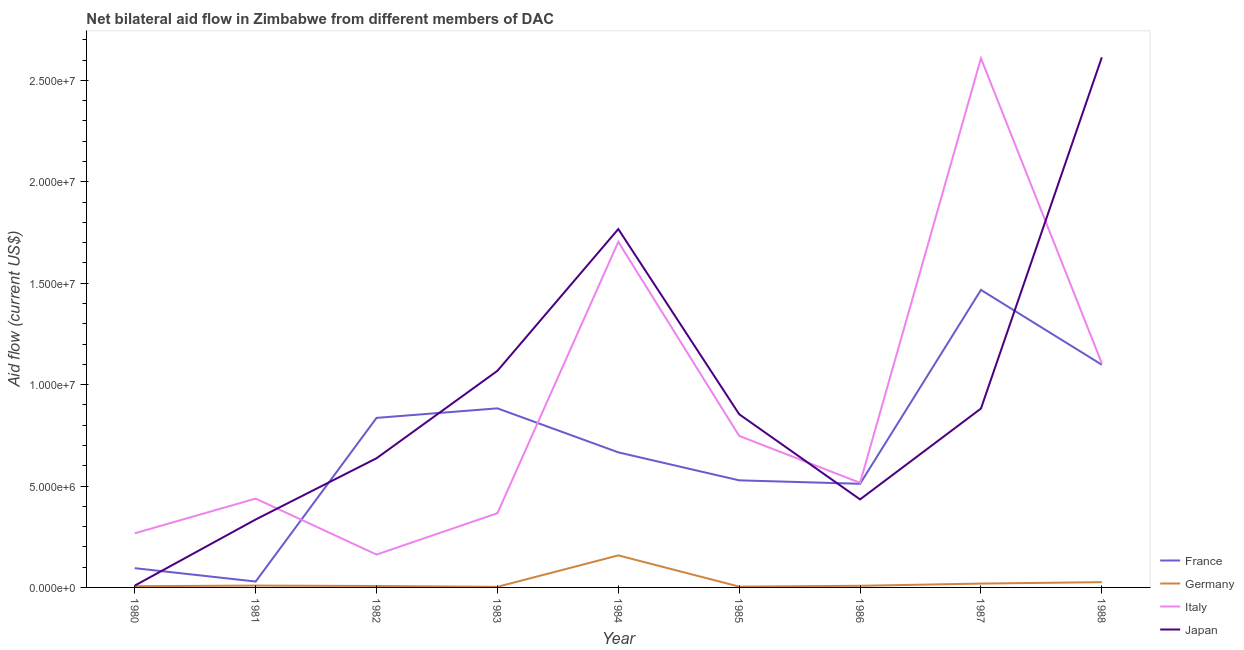How many different coloured lines are there?
Provide a succinct answer. 4. Does the line corresponding to amount of aid given by germany intersect with the line corresponding to amount of aid given by japan?
Offer a very short reply. No. Is the number of lines equal to the number of legend labels?
Your answer should be compact. Yes. What is the amount of aid given by italy in 1983?
Ensure brevity in your answer.  3.66e+06. Across all years, what is the maximum amount of aid given by france?
Keep it short and to the point. 1.47e+07. Across all years, what is the minimum amount of aid given by france?
Give a very brief answer. 2.90e+05. In which year was the amount of aid given by france minimum?
Offer a very short reply. 1981. What is the total amount of aid given by france in the graph?
Provide a short and direct response. 6.11e+07. What is the difference between the amount of aid given by japan in 1980 and that in 1988?
Provide a short and direct response. -2.60e+07. What is the difference between the amount of aid given by france in 1985 and the amount of aid given by italy in 1987?
Ensure brevity in your answer.  -2.08e+07. What is the average amount of aid given by france per year?
Provide a succinct answer. 6.79e+06. In the year 1983, what is the difference between the amount of aid given by germany and amount of aid given by italy?
Keep it short and to the point. -3.63e+06. In how many years, is the amount of aid given by germany greater than 19000000 US$?
Make the answer very short. 0. What is the ratio of the amount of aid given by japan in 1986 to that in 1987?
Offer a very short reply. 0.49. What is the difference between the highest and the second highest amount of aid given by japan?
Make the answer very short. 8.47e+06. What is the difference between the highest and the lowest amount of aid given by italy?
Give a very brief answer. 2.45e+07. In how many years, is the amount of aid given by france greater than the average amount of aid given by france taken over all years?
Keep it short and to the point. 4. Is it the case that in every year, the sum of the amount of aid given by france and amount of aid given by germany is greater than the sum of amount of aid given by japan and amount of aid given by italy?
Your answer should be compact. No. Is it the case that in every year, the sum of the amount of aid given by france and amount of aid given by germany is greater than the amount of aid given by italy?
Offer a very short reply. No. How many years are there in the graph?
Provide a short and direct response. 9. What is the difference between two consecutive major ticks on the Y-axis?
Offer a terse response. 5.00e+06. Are the values on the major ticks of Y-axis written in scientific E-notation?
Offer a very short reply. Yes. Where does the legend appear in the graph?
Provide a short and direct response. Bottom right. How many legend labels are there?
Provide a short and direct response. 4. What is the title of the graph?
Provide a succinct answer. Net bilateral aid flow in Zimbabwe from different members of DAC. Does "Tertiary schools" appear as one of the legend labels in the graph?
Keep it short and to the point. No. What is the label or title of the X-axis?
Keep it short and to the point. Year. What is the Aid flow (current US$) in France in 1980?
Keep it short and to the point. 9.50e+05. What is the Aid flow (current US$) in Germany in 1980?
Your response must be concise. 6.00e+04. What is the Aid flow (current US$) of Italy in 1980?
Offer a terse response. 2.67e+06. What is the Aid flow (current US$) in Japan in 1980?
Give a very brief answer. 9.00e+04. What is the Aid flow (current US$) in Germany in 1981?
Ensure brevity in your answer.  9.00e+04. What is the Aid flow (current US$) of Italy in 1981?
Your response must be concise. 4.38e+06. What is the Aid flow (current US$) of Japan in 1981?
Your answer should be compact. 3.35e+06. What is the Aid flow (current US$) of France in 1982?
Give a very brief answer. 8.36e+06. What is the Aid flow (current US$) in Italy in 1982?
Provide a succinct answer. 1.62e+06. What is the Aid flow (current US$) in Japan in 1982?
Provide a succinct answer. 6.37e+06. What is the Aid flow (current US$) of France in 1983?
Make the answer very short. 8.83e+06. What is the Aid flow (current US$) in Germany in 1983?
Your answer should be very brief. 3.00e+04. What is the Aid flow (current US$) in Italy in 1983?
Provide a succinct answer. 3.66e+06. What is the Aid flow (current US$) of Japan in 1983?
Give a very brief answer. 1.07e+07. What is the Aid flow (current US$) of France in 1984?
Give a very brief answer. 6.66e+06. What is the Aid flow (current US$) in Germany in 1984?
Your answer should be very brief. 1.58e+06. What is the Aid flow (current US$) of Italy in 1984?
Your answer should be very brief. 1.70e+07. What is the Aid flow (current US$) in Japan in 1984?
Make the answer very short. 1.77e+07. What is the Aid flow (current US$) of France in 1985?
Your response must be concise. 5.28e+06. What is the Aid flow (current US$) of Germany in 1985?
Keep it short and to the point. 4.00e+04. What is the Aid flow (current US$) of Italy in 1985?
Keep it short and to the point. 7.47e+06. What is the Aid flow (current US$) of Japan in 1985?
Your answer should be very brief. 8.54e+06. What is the Aid flow (current US$) of France in 1986?
Offer a terse response. 5.11e+06. What is the Aid flow (current US$) in Germany in 1986?
Offer a very short reply. 8.00e+04. What is the Aid flow (current US$) of Italy in 1986?
Offer a very short reply. 5.16e+06. What is the Aid flow (current US$) of Japan in 1986?
Your answer should be compact. 4.34e+06. What is the Aid flow (current US$) of France in 1987?
Your response must be concise. 1.47e+07. What is the Aid flow (current US$) in Italy in 1987?
Ensure brevity in your answer.  2.61e+07. What is the Aid flow (current US$) in Japan in 1987?
Offer a very short reply. 8.82e+06. What is the Aid flow (current US$) of France in 1988?
Your response must be concise. 1.10e+07. What is the Aid flow (current US$) in Italy in 1988?
Make the answer very short. 1.10e+07. What is the Aid flow (current US$) in Japan in 1988?
Offer a very short reply. 2.61e+07. Across all years, what is the maximum Aid flow (current US$) of France?
Make the answer very short. 1.47e+07. Across all years, what is the maximum Aid flow (current US$) of Germany?
Provide a succinct answer. 1.58e+06. Across all years, what is the maximum Aid flow (current US$) in Italy?
Ensure brevity in your answer.  2.61e+07. Across all years, what is the maximum Aid flow (current US$) of Japan?
Provide a short and direct response. 2.61e+07. Across all years, what is the minimum Aid flow (current US$) in Germany?
Your response must be concise. 3.00e+04. Across all years, what is the minimum Aid flow (current US$) in Italy?
Provide a succinct answer. 1.62e+06. Across all years, what is the minimum Aid flow (current US$) in Japan?
Make the answer very short. 9.00e+04. What is the total Aid flow (current US$) in France in the graph?
Provide a succinct answer. 6.11e+07. What is the total Aid flow (current US$) of Germany in the graph?
Keep it short and to the point. 2.40e+06. What is the total Aid flow (current US$) of Italy in the graph?
Your answer should be compact. 7.91e+07. What is the total Aid flow (current US$) of Japan in the graph?
Provide a succinct answer. 8.60e+07. What is the difference between the Aid flow (current US$) in France in 1980 and that in 1981?
Provide a short and direct response. 6.60e+05. What is the difference between the Aid flow (current US$) in Germany in 1980 and that in 1981?
Provide a succinct answer. -3.00e+04. What is the difference between the Aid flow (current US$) of Italy in 1980 and that in 1981?
Your answer should be compact. -1.71e+06. What is the difference between the Aid flow (current US$) in Japan in 1980 and that in 1981?
Your answer should be very brief. -3.26e+06. What is the difference between the Aid flow (current US$) in France in 1980 and that in 1982?
Provide a short and direct response. -7.41e+06. What is the difference between the Aid flow (current US$) in Italy in 1980 and that in 1982?
Keep it short and to the point. 1.05e+06. What is the difference between the Aid flow (current US$) in Japan in 1980 and that in 1982?
Offer a terse response. -6.28e+06. What is the difference between the Aid flow (current US$) in France in 1980 and that in 1983?
Offer a terse response. -7.88e+06. What is the difference between the Aid flow (current US$) of Italy in 1980 and that in 1983?
Keep it short and to the point. -9.90e+05. What is the difference between the Aid flow (current US$) in Japan in 1980 and that in 1983?
Provide a short and direct response. -1.06e+07. What is the difference between the Aid flow (current US$) of France in 1980 and that in 1984?
Offer a very short reply. -5.71e+06. What is the difference between the Aid flow (current US$) of Germany in 1980 and that in 1984?
Provide a short and direct response. -1.52e+06. What is the difference between the Aid flow (current US$) of Italy in 1980 and that in 1984?
Your response must be concise. -1.44e+07. What is the difference between the Aid flow (current US$) in Japan in 1980 and that in 1984?
Offer a very short reply. -1.76e+07. What is the difference between the Aid flow (current US$) in France in 1980 and that in 1985?
Give a very brief answer. -4.33e+06. What is the difference between the Aid flow (current US$) in Germany in 1980 and that in 1985?
Provide a succinct answer. 2.00e+04. What is the difference between the Aid flow (current US$) in Italy in 1980 and that in 1985?
Offer a very short reply. -4.80e+06. What is the difference between the Aid flow (current US$) of Japan in 1980 and that in 1985?
Make the answer very short. -8.45e+06. What is the difference between the Aid flow (current US$) in France in 1980 and that in 1986?
Offer a terse response. -4.16e+06. What is the difference between the Aid flow (current US$) of Italy in 1980 and that in 1986?
Offer a very short reply. -2.49e+06. What is the difference between the Aid flow (current US$) of Japan in 1980 and that in 1986?
Provide a succinct answer. -4.25e+06. What is the difference between the Aid flow (current US$) of France in 1980 and that in 1987?
Provide a succinct answer. -1.37e+07. What is the difference between the Aid flow (current US$) in Italy in 1980 and that in 1987?
Ensure brevity in your answer.  -2.34e+07. What is the difference between the Aid flow (current US$) in Japan in 1980 and that in 1987?
Provide a short and direct response. -8.73e+06. What is the difference between the Aid flow (current US$) of France in 1980 and that in 1988?
Offer a very short reply. -1.00e+07. What is the difference between the Aid flow (current US$) of Italy in 1980 and that in 1988?
Provide a succinct answer. -8.38e+06. What is the difference between the Aid flow (current US$) of Japan in 1980 and that in 1988?
Your answer should be very brief. -2.60e+07. What is the difference between the Aid flow (current US$) of France in 1981 and that in 1982?
Provide a short and direct response. -8.07e+06. What is the difference between the Aid flow (current US$) in Germany in 1981 and that in 1982?
Your response must be concise. 2.00e+04. What is the difference between the Aid flow (current US$) of Italy in 1981 and that in 1982?
Make the answer very short. 2.76e+06. What is the difference between the Aid flow (current US$) in Japan in 1981 and that in 1982?
Provide a succinct answer. -3.02e+06. What is the difference between the Aid flow (current US$) in France in 1981 and that in 1983?
Offer a terse response. -8.54e+06. What is the difference between the Aid flow (current US$) in Italy in 1981 and that in 1983?
Offer a terse response. 7.20e+05. What is the difference between the Aid flow (current US$) in Japan in 1981 and that in 1983?
Make the answer very short. -7.33e+06. What is the difference between the Aid flow (current US$) in France in 1981 and that in 1984?
Provide a succinct answer. -6.37e+06. What is the difference between the Aid flow (current US$) of Germany in 1981 and that in 1984?
Offer a terse response. -1.49e+06. What is the difference between the Aid flow (current US$) in Italy in 1981 and that in 1984?
Offer a terse response. -1.27e+07. What is the difference between the Aid flow (current US$) in Japan in 1981 and that in 1984?
Offer a terse response. -1.43e+07. What is the difference between the Aid flow (current US$) in France in 1981 and that in 1985?
Keep it short and to the point. -4.99e+06. What is the difference between the Aid flow (current US$) in Germany in 1981 and that in 1985?
Offer a terse response. 5.00e+04. What is the difference between the Aid flow (current US$) of Italy in 1981 and that in 1985?
Offer a terse response. -3.09e+06. What is the difference between the Aid flow (current US$) in Japan in 1981 and that in 1985?
Give a very brief answer. -5.19e+06. What is the difference between the Aid flow (current US$) in France in 1981 and that in 1986?
Your response must be concise. -4.82e+06. What is the difference between the Aid flow (current US$) of Italy in 1981 and that in 1986?
Your response must be concise. -7.80e+05. What is the difference between the Aid flow (current US$) of Japan in 1981 and that in 1986?
Provide a succinct answer. -9.90e+05. What is the difference between the Aid flow (current US$) of France in 1981 and that in 1987?
Offer a very short reply. -1.44e+07. What is the difference between the Aid flow (current US$) in Italy in 1981 and that in 1987?
Keep it short and to the point. -2.17e+07. What is the difference between the Aid flow (current US$) of Japan in 1981 and that in 1987?
Keep it short and to the point. -5.47e+06. What is the difference between the Aid flow (current US$) of France in 1981 and that in 1988?
Keep it short and to the point. -1.07e+07. What is the difference between the Aid flow (current US$) in Germany in 1981 and that in 1988?
Offer a very short reply. -1.70e+05. What is the difference between the Aid flow (current US$) of Italy in 1981 and that in 1988?
Make the answer very short. -6.67e+06. What is the difference between the Aid flow (current US$) in Japan in 1981 and that in 1988?
Offer a terse response. -2.28e+07. What is the difference between the Aid flow (current US$) of France in 1982 and that in 1983?
Provide a short and direct response. -4.70e+05. What is the difference between the Aid flow (current US$) in Germany in 1982 and that in 1983?
Your response must be concise. 4.00e+04. What is the difference between the Aid flow (current US$) in Italy in 1982 and that in 1983?
Your answer should be compact. -2.04e+06. What is the difference between the Aid flow (current US$) of Japan in 1982 and that in 1983?
Provide a short and direct response. -4.31e+06. What is the difference between the Aid flow (current US$) of France in 1982 and that in 1984?
Your answer should be very brief. 1.70e+06. What is the difference between the Aid flow (current US$) of Germany in 1982 and that in 1984?
Give a very brief answer. -1.51e+06. What is the difference between the Aid flow (current US$) of Italy in 1982 and that in 1984?
Keep it short and to the point. -1.54e+07. What is the difference between the Aid flow (current US$) of Japan in 1982 and that in 1984?
Ensure brevity in your answer.  -1.13e+07. What is the difference between the Aid flow (current US$) of France in 1982 and that in 1985?
Your answer should be very brief. 3.08e+06. What is the difference between the Aid flow (current US$) of Italy in 1982 and that in 1985?
Your response must be concise. -5.85e+06. What is the difference between the Aid flow (current US$) of Japan in 1982 and that in 1985?
Provide a short and direct response. -2.17e+06. What is the difference between the Aid flow (current US$) of France in 1982 and that in 1986?
Ensure brevity in your answer.  3.25e+06. What is the difference between the Aid flow (current US$) of Germany in 1982 and that in 1986?
Make the answer very short. -10000. What is the difference between the Aid flow (current US$) of Italy in 1982 and that in 1986?
Keep it short and to the point. -3.54e+06. What is the difference between the Aid flow (current US$) of Japan in 1982 and that in 1986?
Give a very brief answer. 2.03e+06. What is the difference between the Aid flow (current US$) in France in 1982 and that in 1987?
Your answer should be compact. -6.31e+06. What is the difference between the Aid flow (current US$) of Italy in 1982 and that in 1987?
Your answer should be compact. -2.45e+07. What is the difference between the Aid flow (current US$) of Japan in 1982 and that in 1987?
Your answer should be very brief. -2.45e+06. What is the difference between the Aid flow (current US$) in France in 1982 and that in 1988?
Provide a short and direct response. -2.62e+06. What is the difference between the Aid flow (current US$) of Germany in 1982 and that in 1988?
Your answer should be compact. -1.90e+05. What is the difference between the Aid flow (current US$) in Italy in 1982 and that in 1988?
Offer a very short reply. -9.43e+06. What is the difference between the Aid flow (current US$) of Japan in 1982 and that in 1988?
Give a very brief answer. -1.98e+07. What is the difference between the Aid flow (current US$) of France in 1983 and that in 1984?
Your answer should be compact. 2.17e+06. What is the difference between the Aid flow (current US$) in Germany in 1983 and that in 1984?
Offer a very short reply. -1.55e+06. What is the difference between the Aid flow (current US$) of Italy in 1983 and that in 1984?
Provide a succinct answer. -1.34e+07. What is the difference between the Aid flow (current US$) in Japan in 1983 and that in 1984?
Make the answer very short. -6.99e+06. What is the difference between the Aid flow (current US$) in France in 1983 and that in 1985?
Your response must be concise. 3.55e+06. What is the difference between the Aid flow (current US$) in Italy in 1983 and that in 1985?
Keep it short and to the point. -3.81e+06. What is the difference between the Aid flow (current US$) in Japan in 1983 and that in 1985?
Your answer should be compact. 2.14e+06. What is the difference between the Aid flow (current US$) in France in 1983 and that in 1986?
Provide a succinct answer. 3.72e+06. What is the difference between the Aid flow (current US$) in Italy in 1983 and that in 1986?
Offer a very short reply. -1.50e+06. What is the difference between the Aid flow (current US$) of Japan in 1983 and that in 1986?
Your response must be concise. 6.34e+06. What is the difference between the Aid flow (current US$) of France in 1983 and that in 1987?
Keep it short and to the point. -5.84e+06. What is the difference between the Aid flow (current US$) in Germany in 1983 and that in 1987?
Give a very brief answer. -1.60e+05. What is the difference between the Aid flow (current US$) of Italy in 1983 and that in 1987?
Your response must be concise. -2.24e+07. What is the difference between the Aid flow (current US$) in Japan in 1983 and that in 1987?
Your answer should be very brief. 1.86e+06. What is the difference between the Aid flow (current US$) in France in 1983 and that in 1988?
Offer a terse response. -2.15e+06. What is the difference between the Aid flow (current US$) in Italy in 1983 and that in 1988?
Offer a very short reply. -7.39e+06. What is the difference between the Aid flow (current US$) of Japan in 1983 and that in 1988?
Offer a terse response. -1.55e+07. What is the difference between the Aid flow (current US$) of France in 1984 and that in 1985?
Offer a terse response. 1.38e+06. What is the difference between the Aid flow (current US$) in Germany in 1984 and that in 1985?
Keep it short and to the point. 1.54e+06. What is the difference between the Aid flow (current US$) in Italy in 1984 and that in 1985?
Keep it short and to the point. 9.57e+06. What is the difference between the Aid flow (current US$) in Japan in 1984 and that in 1985?
Give a very brief answer. 9.13e+06. What is the difference between the Aid flow (current US$) in France in 1984 and that in 1986?
Keep it short and to the point. 1.55e+06. What is the difference between the Aid flow (current US$) of Germany in 1984 and that in 1986?
Your answer should be very brief. 1.50e+06. What is the difference between the Aid flow (current US$) of Italy in 1984 and that in 1986?
Give a very brief answer. 1.19e+07. What is the difference between the Aid flow (current US$) of Japan in 1984 and that in 1986?
Offer a very short reply. 1.33e+07. What is the difference between the Aid flow (current US$) of France in 1984 and that in 1987?
Your answer should be very brief. -8.01e+06. What is the difference between the Aid flow (current US$) in Germany in 1984 and that in 1987?
Ensure brevity in your answer.  1.39e+06. What is the difference between the Aid flow (current US$) of Italy in 1984 and that in 1987?
Give a very brief answer. -9.05e+06. What is the difference between the Aid flow (current US$) of Japan in 1984 and that in 1987?
Your answer should be very brief. 8.85e+06. What is the difference between the Aid flow (current US$) of France in 1984 and that in 1988?
Your answer should be very brief. -4.32e+06. What is the difference between the Aid flow (current US$) in Germany in 1984 and that in 1988?
Offer a very short reply. 1.32e+06. What is the difference between the Aid flow (current US$) of Italy in 1984 and that in 1988?
Your answer should be compact. 5.99e+06. What is the difference between the Aid flow (current US$) in Japan in 1984 and that in 1988?
Keep it short and to the point. -8.47e+06. What is the difference between the Aid flow (current US$) of France in 1985 and that in 1986?
Your response must be concise. 1.70e+05. What is the difference between the Aid flow (current US$) in Italy in 1985 and that in 1986?
Provide a succinct answer. 2.31e+06. What is the difference between the Aid flow (current US$) in Japan in 1985 and that in 1986?
Provide a short and direct response. 4.20e+06. What is the difference between the Aid flow (current US$) in France in 1985 and that in 1987?
Provide a succinct answer. -9.39e+06. What is the difference between the Aid flow (current US$) in Germany in 1985 and that in 1987?
Provide a short and direct response. -1.50e+05. What is the difference between the Aid flow (current US$) in Italy in 1985 and that in 1987?
Keep it short and to the point. -1.86e+07. What is the difference between the Aid flow (current US$) in Japan in 1985 and that in 1987?
Offer a very short reply. -2.80e+05. What is the difference between the Aid flow (current US$) in France in 1985 and that in 1988?
Your answer should be very brief. -5.70e+06. What is the difference between the Aid flow (current US$) of Germany in 1985 and that in 1988?
Provide a succinct answer. -2.20e+05. What is the difference between the Aid flow (current US$) in Italy in 1985 and that in 1988?
Ensure brevity in your answer.  -3.58e+06. What is the difference between the Aid flow (current US$) of Japan in 1985 and that in 1988?
Offer a very short reply. -1.76e+07. What is the difference between the Aid flow (current US$) in France in 1986 and that in 1987?
Make the answer very short. -9.56e+06. What is the difference between the Aid flow (current US$) in Italy in 1986 and that in 1987?
Offer a terse response. -2.09e+07. What is the difference between the Aid flow (current US$) of Japan in 1986 and that in 1987?
Offer a terse response. -4.48e+06. What is the difference between the Aid flow (current US$) of France in 1986 and that in 1988?
Offer a very short reply. -5.87e+06. What is the difference between the Aid flow (current US$) in Germany in 1986 and that in 1988?
Make the answer very short. -1.80e+05. What is the difference between the Aid flow (current US$) in Italy in 1986 and that in 1988?
Make the answer very short. -5.89e+06. What is the difference between the Aid flow (current US$) in Japan in 1986 and that in 1988?
Your response must be concise. -2.18e+07. What is the difference between the Aid flow (current US$) of France in 1987 and that in 1988?
Provide a succinct answer. 3.69e+06. What is the difference between the Aid flow (current US$) in Italy in 1987 and that in 1988?
Offer a terse response. 1.50e+07. What is the difference between the Aid flow (current US$) of Japan in 1987 and that in 1988?
Your answer should be very brief. -1.73e+07. What is the difference between the Aid flow (current US$) of France in 1980 and the Aid flow (current US$) of Germany in 1981?
Provide a succinct answer. 8.60e+05. What is the difference between the Aid flow (current US$) of France in 1980 and the Aid flow (current US$) of Italy in 1981?
Make the answer very short. -3.43e+06. What is the difference between the Aid flow (current US$) of France in 1980 and the Aid flow (current US$) of Japan in 1981?
Offer a very short reply. -2.40e+06. What is the difference between the Aid flow (current US$) of Germany in 1980 and the Aid flow (current US$) of Italy in 1981?
Offer a terse response. -4.32e+06. What is the difference between the Aid flow (current US$) of Germany in 1980 and the Aid flow (current US$) of Japan in 1981?
Your answer should be compact. -3.29e+06. What is the difference between the Aid flow (current US$) in Italy in 1980 and the Aid flow (current US$) in Japan in 1981?
Give a very brief answer. -6.80e+05. What is the difference between the Aid flow (current US$) in France in 1980 and the Aid flow (current US$) in Germany in 1982?
Your answer should be compact. 8.80e+05. What is the difference between the Aid flow (current US$) in France in 1980 and the Aid flow (current US$) in Italy in 1982?
Make the answer very short. -6.70e+05. What is the difference between the Aid flow (current US$) of France in 1980 and the Aid flow (current US$) of Japan in 1982?
Offer a very short reply. -5.42e+06. What is the difference between the Aid flow (current US$) in Germany in 1980 and the Aid flow (current US$) in Italy in 1982?
Give a very brief answer. -1.56e+06. What is the difference between the Aid flow (current US$) in Germany in 1980 and the Aid flow (current US$) in Japan in 1982?
Your response must be concise. -6.31e+06. What is the difference between the Aid flow (current US$) in Italy in 1980 and the Aid flow (current US$) in Japan in 1982?
Provide a short and direct response. -3.70e+06. What is the difference between the Aid flow (current US$) in France in 1980 and the Aid flow (current US$) in Germany in 1983?
Make the answer very short. 9.20e+05. What is the difference between the Aid flow (current US$) in France in 1980 and the Aid flow (current US$) in Italy in 1983?
Ensure brevity in your answer.  -2.71e+06. What is the difference between the Aid flow (current US$) of France in 1980 and the Aid flow (current US$) of Japan in 1983?
Keep it short and to the point. -9.73e+06. What is the difference between the Aid flow (current US$) of Germany in 1980 and the Aid flow (current US$) of Italy in 1983?
Make the answer very short. -3.60e+06. What is the difference between the Aid flow (current US$) in Germany in 1980 and the Aid flow (current US$) in Japan in 1983?
Provide a short and direct response. -1.06e+07. What is the difference between the Aid flow (current US$) of Italy in 1980 and the Aid flow (current US$) of Japan in 1983?
Offer a terse response. -8.01e+06. What is the difference between the Aid flow (current US$) in France in 1980 and the Aid flow (current US$) in Germany in 1984?
Offer a terse response. -6.30e+05. What is the difference between the Aid flow (current US$) of France in 1980 and the Aid flow (current US$) of Italy in 1984?
Your answer should be very brief. -1.61e+07. What is the difference between the Aid flow (current US$) of France in 1980 and the Aid flow (current US$) of Japan in 1984?
Keep it short and to the point. -1.67e+07. What is the difference between the Aid flow (current US$) of Germany in 1980 and the Aid flow (current US$) of Italy in 1984?
Ensure brevity in your answer.  -1.70e+07. What is the difference between the Aid flow (current US$) of Germany in 1980 and the Aid flow (current US$) of Japan in 1984?
Give a very brief answer. -1.76e+07. What is the difference between the Aid flow (current US$) of Italy in 1980 and the Aid flow (current US$) of Japan in 1984?
Offer a very short reply. -1.50e+07. What is the difference between the Aid flow (current US$) in France in 1980 and the Aid flow (current US$) in Germany in 1985?
Give a very brief answer. 9.10e+05. What is the difference between the Aid flow (current US$) of France in 1980 and the Aid flow (current US$) of Italy in 1985?
Your answer should be very brief. -6.52e+06. What is the difference between the Aid flow (current US$) of France in 1980 and the Aid flow (current US$) of Japan in 1985?
Make the answer very short. -7.59e+06. What is the difference between the Aid flow (current US$) of Germany in 1980 and the Aid flow (current US$) of Italy in 1985?
Your response must be concise. -7.41e+06. What is the difference between the Aid flow (current US$) in Germany in 1980 and the Aid flow (current US$) in Japan in 1985?
Your answer should be very brief. -8.48e+06. What is the difference between the Aid flow (current US$) of Italy in 1980 and the Aid flow (current US$) of Japan in 1985?
Provide a succinct answer. -5.87e+06. What is the difference between the Aid flow (current US$) of France in 1980 and the Aid flow (current US$) of Germany in 1986?
Ensure brevity in your answer.  8.70e+05. What is the difference between the Aid flow (current US$) in France in 1980 and the Aid flow (current US$) in Italy in 1986?
Offer a terse response. -4.21e+06. What is the difference between the Aid flow (current US$) in France in 1980 and the Aid flow (current US$) in Japan in 1986?
Keep it short and to the point. -3.39e+06. What is the difference between the Aid flow (current US$) of Germany in 1980 and the Aid flow (current US$) of Italy in 1986?
Provide a succinct answer. -5.10e+06. What is the difference between the Aid flow (current US$) of Germany in 1980 and the Aid flow (current US$) of Japan in 1986?
Your answer should be compact. -4.28e+06. What is the difference between the Aid flow (current US$) of Italy in 1980 and the Aid flow (current US$) of Japan in 1986?
Offer a very short reply. -1.67e+06. What is the difference between the Aid flow (current US$) in France in 1980 and the Aid flow (current US$) in Germany in 1987?
Keep it short and to the point. 7.60e+05. What is the difference between the Aid flow (current US$) of France in 1980 and the Aid flow (current US$) of Italy in 1987?
Ensure brevity in your answer.  -2.51e+07. What is the difference between the Aid flow (current US$) in France in 1980 and the Aid flow (current US$) in Japan in 1987?
Provide a short and direct response. -7.87e+06. What is the difference between the Aid flow (current US$) in Germany in 1980 and the Aid flow (current US$) in Italy in 1987?
Ensure brevity in your answer.  -2.60e+07. What is the difference between the Aid flow (current US$) in Germany in 1980 and the Aid flow (current US$) in Japan in 1987?
Provide a succinct answer. -8.76e+06. What is the difference between the Aid flow (current US$) in Italy in 1980 and the Aid flow (current US$) in Japan in 1987?
Your answer should be compact. -6.15e+06. What is the difference between the Aid flow (current US$) in France in 1980 and the Aid flow (current US$) in Germany in 1988?
Provide a short and direct response. 6.90e+05. What is the difference between the Aid flow (current US$) of France in 1980 and the Aid flow (current US$) of Italy in 1988?
Give a very brief answer. -1.01e+07. What is the difference between the Aid flow (current US$) of France in 1980 and the Aid flow (current US$) of Japan in 1988?
Your answer should be very brief. -2.52e+07. What is the difference between the Aid flow (current US$) of Germany in 1980 and the Aid flow (current US$) of Italy in 1988?
Provide a short and direct response. -1.10e+07. What is the difference between the Aid flow (current US$) in Germany in 1980 and the Aid flow (current US$) in Japan in 1988?
Your answer should be very brief. -2.61e+07. What is the difference between the Aid flow (current US$) in Italy in 1980 and the Aid flow (current US$) in Japan in 1988?
Keep it short and to the point. -2.35e+07. What is the difference between the Aid flow (current US$) of France in 1981 and the Aid flow (current US$) of Italy in 1982?
Provide a short and direct response. -1.33e+06. What is the difference between the Aid flow (current US$) of France in 1981 and the Aid flow (current US$) of Japan in 1982?
Your response must be concise. -6.08e+06. What is the difference between the Aid flow (current US$) of Germany in 1981 and the Aid flow (current US$) of Italy in 1982?
Offer a terse response. -1.53e+06. What is the difference between the Aid flow (current US$) in Germany in 1981 and the Aid flow (current US$) in Japan in 1982?
Your response must be concise. -6.28e+06. What is the difference between the Aid flow (current US$) of Italy in 1981 and the Aid flow (current US$) of Japan in 1982?
Keep it short and to the point. -1.99e+06. What is the difference between the Aid flow (current US$) in France in 1981 and the Aid flow (current US$) in Italy in 1983?
Your answer should be compact. -3.37e+06. What is the difference between the Aid flow (current US$) in France in 1981 and the Aid flow (current US$) in Japan in 1983?
Offer a terse response. -1.04e+07. What is the difference between the Aid flow (current US$) in Germany in 1981 and the Aid flow (current US$) in Italy in 1983?
Keep it short and to the point. -3.57e+06. What is the difference between the Aid flow (current US$) of Germany in 1981 and the Aid flow (current US$) of Japan in 1983?
Keep it short and to the point. -1.06e+07. What is the difference between the Aid flow (current US$) in Italy in 1981 and the Aid flow (current US$) in Japan in 1983?
Provide a succinct answer. -6.30e+06. What is the difference between the Aid flow (current US$) in France in 1981 and the Aid flow (current US$) in Germany in 1984?
Your response must be concise. -1.29e+06. What is the difference between the Aid flow (current US$) of France in 1981 and the Aid flow (current US$) of Italy in 1984?
Provide a succinct answer. -1.68e+07. What is the difference between the Aid flow (current US$) in France in 1981 and the Aid flow (current US$) in Japan in 1984?
Your response must be concise. -1.74e+07. What is the difference between the Aid flow (current US$) in Germany in 1981 and the Aid flow (current US$) in Italy in 1984?
Offer a very short reply. -1.70e+07. What is the difference between the Aid flow (current US$) of Germany in 1981 and the Aid flow (current US$) of Japan in 1984?
Keep it short and to the point. -1.76e+07. What is the difference between the Aid flow (current US$) of Italy in 1981 and the Aid flow (current US$) of Japan in 1984?
Your response must be concise. -1.33e+07. What is the difference between the Aid flow (current US$) in France in 1981 and the Aid flow (current US$) in Germany in 1985?
Ensure brevity in your answer.  2.50e+05. What is the difference between the Aid flow (current US$) of France in 1981 and the Aid flow (current US$) of Italy in 1985?
Make the answer very short. -7.18e+06. What is the difference between the Aid flow (current US$) in France in 1981 and the Aid flow (current US$) in Japan in 1985?
Your answer should be very brief. -8.25e+06. What is the difference between the Aid flow (current US$) of Germany in 1981 and the Aid flow (current US$) of Italy in 1985?
Provide a short and direct response. -7.38e+06. What is the difference between the Aid flow (current US$) in Germany in 1981 and the Aid flow (current US$) in Japan in 1985?
Ensure brevity in your answer.  -8.45e+06. What is the difference between the Aid flow (current US$) of Italy in 1981 and the Aid flow (current US$) of Japan in 1985?
Your answer should be very brief. -4.16e+06. What is the difference between the Aid flow (current US$) of France in 1981 and the Aid flow (current US$) of Italy in 1986?
Offer a terse response. -4.87e+06. What is the difference between the Aid flow (current US$) in France in 1981 and the Aid flow (current US$) in Japan in 1986?
Your answer should be compact. -4.05e+06. What is the difference between the Aid flow (current US$) in Germany in 1981 and the Aid flow (current US$) in Italy in 1986?
Your answer should be compact. -5.07e+06. What is the difference between the Aid flow (current US$) in Germany in 1981 and the Aid flow (current US$) in Japan in 1986?
Offer a terse response. -4.25e+06. What is the difference between the Aid flow (current US$) in France in 1981 and the Aid flow (current US$) in Germany in 1987?
Keep it short and to the point. 1.00e+05. What is the difference between the Aid flow (current US$) of France in 1981 and the Aid flow (current US$) of Italy in 1987?
Provide a short and direct response. -2.58e+07. What is the difference between the Aid flow (current US$) in France in 1981 and the Aid flow (current US$) in Japan in 1987?
Your answer should be compact. -8.53e+06. What is the difference between the Aid flow (current US$) in Germany in 1981 and the Aid flow (current US$) in Italy in 1987?
Your answer should be compact. -2.60e+07. What is the difference between the Aid flow (current US$) of Germany in 1981 and the Aid flow (current US$) of Japan in 1987?
Offer a terse response. -8.73e+06. What is the difference between the Aid flow (current US$) of Italy in 1981 and the Aid flow (current US$) of Japan in 1987?
Your answer should be very brief. -4.44e+06. What is the difference between the Aid flow (current US$) of France in 1981 and the Aid flow (current US$) of Germany in 1988?
Give a very brief answer. 3.00e+04. What is the difference between the Aid flow (current US$) in France in 1981 and the Aid flow (current US$) in Italy in 1988?
Your answer should be compact. -1.08e+07. What is the difference between the Aid flow (current US$) of France in 1981 and the Aid flow (current US$) of Japan in 1988?
Provide a succinct answer. -2.58e+07. What is the difference between the Aid flow (current US$) in Germany in 1981 and the Aid flow (current US$) in Italy in 1988?
Keep it short and to the point. -1.10e+07. What is the difference between the Aid flow (current US$) of Germany in 1981 and the Aid flow (current US$) of Japan in 1988?
Your answer should be very brief. -2.60e+07. What is the difference between the Aid flow (current US$) in Italy in 1981 and the Aid flow (current US$) in Japan in 1988?
Give a very brief answer. -2.18e+07. What is the difference between the Aid flow (current US$) of France in 1982 and the Aid flow (current US$) of Germany in 1983?
Keep it short and to the point. 8.33e+06. What is the difference between the Aid flow (current US$) in France in 1982 and the Aid flow (current US$) in Italy in 1983?
Your answer should be very brief. 4.70e+06. What is the difference between the Aid flow (current US$) of France in 1982 and the Aid flow (current US$) of Japan in 1983?
Offer a very short reply. -2.32e+06. What is the difference between the Aid flow (current US$) in Germany in 1982 and the Aid flow (current US$) in Italy in 1983?
Provide a short and direct response. -3.59e+06. What is the difference between the Aid flow (current US$) of Germany in 1982 and the Aid flow (current US$) of Japan in 1983?
Offer a terse response. -1.06e+07. What is the difference between the Aid flow (current US$) of Italy in 1982 and the Aid flow (current US$) of Japan in 1983?
Your response must be concise. -9.06e+06. What is the difference between the Aid flow (current US$) in France in 1982 and the Aid flow (current US$) in Germany in 1984?
Your answer should be very brief. 6.78e+06. What is the difference between the Aid flow (current US$) in France in 1982 and the Aid flow (current US$) in Italy in 1984?
Ensure brevity in your answer.  -8.68e+06. What is the difference between the Aid flow (current US$) in France in 1982 and the Aid flow (current US$) in Japan in 1984?
Make the answer very short. -9.31e+06. What is the difference between the Aid flow (current US$) of Germany in 1982 and the Aid flow (current US$) of Italy in 1984?
Offer a terse response. -1.70e+07. What is the difference between the Aid flow (current US$) in Germany in 1982 and the Aid flow (current US$) in Japan in 1984?
Provide a short and direct response. -1.76e+07. What is the difference between the Aid flow (current US$) of Italy in 1982 and the Aid flow (current US$) of Japan in 1984?
Keep it short and to the point. -1.60e+07. What is the difference between the Aid flow (current US$) in France in 1982 and the Aid flow (current US$) in Germany in 1985?
Your response must be concise. 8.32e+06. What is the difference between the Aid flow (current US$) of France in 1982 and the Aid flow (current US$) of Italy in 1985?
Offer a terse response. 8.90e+05. What is the difference between the Aid flow (current US$) of Germany in 1982 and the Aid flow (current US$) of Italy in 1985?
Ensure brevity in your answer.  -7.40e+06. What is the difference between the Aid flow (current US$) in Germany in 1982 and the Aid flow (current US$) in Japan in 1985?
Offer a very short reply. -8.47e+06. What is the difference between the Aid flow (current US$) of Italy in 1982 and the Aid flow (current US$) of Japan in 1985?
Provide a short and direct response. -6.92e+06. What is the difference between the Aid flow (current US$) of France in 1982 and the Aid flow (current US$) of Germany in 1986?
Make the answer very short. 8.28e+06. What is the difference between the Aid flow (current US$) of France in 1982 and the Aid flow (current US$) of Italy in 1986?
Your response must be concise. 3.20e+06. What is the difference between the Aid flow (current US$) of France in 1982 and the Aid flow (current US$) of Japan in 1986?
Provide a succinct answer. 4.02e+06. What is the difference between the Aid flow (current US$) in Germany in 1982 and the Aid flow (current US$) in Italy in 1986?
Your answer should be compact. -5.09e+06. What is the difference between the Aid flow (current US$) of Germany in 1982 and the Aid flow (current US$) of Japan in 1986?
Your response must be concise. -4.27e+06. What is the difference between the Aid flow (current US$) of Italy in 1982 and the Aid flow (current US$) of Japan in 1986?
Offer a very short reply. -2.72e+06. What is the difference between the Aid flow (current US$) of France in 1982 and the Aid flow (current US$) of Germany in 1987?
Provide a succinct answer. 8.17e+06. What is the difference between the Aid flow (current US$) in France in 1982 and the Aid flow (current US$) in Italy in 1987?
Give a very brief answer. -1.77e+07. What is the difference between the Aid flow (current US$) of France in 1982 and the Aid flow (current US$) of Japan in 1987?
Your response must be concise. -4.60e+05. What is the difference between the Aid flow (current US$) in Germany in 1982 and the Aid flow (current US$) in Italy in 1987?
Offer a terse response. -2.60e+07. What is the difference between the Aid flow (current US$) in Germany in 1982 and the Aid flow (current US$) in Japan in 1987?
Give a very brief answer. -8.75e+06. What is the difference between the Aid flow (current US$) in Italy in 1982 and the Aid flow (current US$) in Japan in 1987?
Make the answer very short. -7.20e+06. What is the difference between the Aid flow (current US$) in France in 1982 and the Aid flow (current US$) in Germany in 1988?
Your answer should be very brief. 8.10e+06. What is the difference between the Aid flow (current US$) in France in 1982 and the Aid flow (current US$) in Italy in 1988?
Your answer should be very brief. -2.69e+06. What is the difference between the Aid flow (current US$) of France in 1982 and the Aid flow (current US$) of Japan in 1988?
Offer a terse response. -1.78e+07. What is the difference between the Aid flow (current US$) of Germany in 1982 and the Aid flow (current US$) of Italy in 1988?
Offer a very short reply. -1.10e+07. What is the difference between the Aid flow (current US$) in Germany in 1982 and the Aid flow (current US$) in Japan in 1988?
Give a very brief answer. -2.61e+07. What is the difference between the Aid flow (current US$) of Italy in 1982 and the Aid flow (current US$) of Japan in 1988?
Make the answer very short. -2.45e+07. What is the difference between the Aid flow (current US$) of France in 1983 and the Aid flow (current US$) of Germany in 1984?
Provide a succinct answer. 7.25e+06. What is the difference between the Aid flow (current US$) in France in 1983 and the Aid flow (current US$) in Italy in 1984?
Offer a very short reply. -8.21e+06. What is the difference between the Aid flow (current US$) in France in 1983 and the Aid flow (current US$) in Japan in 1984?
Make the answer very short. -8.84e+06. What is the difference between the Aid flow (current US$) in Germany in 1983 and the Aid flow (current US$) in Italy in 1984?
Offer a very short reply. -1.70e+07. What is the difference between the Aid flow (current US$) in Germany in 1983 and the Aid flow (current US$) in Japan in 1984?
Your answer should be very brief. -1.76e+07. What is the difference between the Aid flow (current US$) in Italy in 1983 and the Aid flow (current US$) in Japan in 1984?
Provide a short and direct response. -1.40e+07. What is the difference between the Aid flow (current US$) in France in 1983 and the Aid flow (current US$) in Germany in 1985?
Ensure brevity in your answer.  8.79e+06. What is the difference between the Aid flow (current US$) in France in 1983 and the Aid flow (current US$) in Italy in 1985?
Offer a terse response. 1.36e+06. What is the difference between the Aid flow (current US$) in France in 1983 and the Aid flow (current US$) in Japan in 1985?
Make the answer very short. 2.90e+05. What is the difference between the Aid flow (current US$) in Germany in 1983 and the Aid flow (current US$) in Italy in 1985?
Offer a terse response. -7.44e+06. What is the difference between the Aid flow (current US$) in Germany in 1983 and the Aid flow (current US$) in Japan in 1985?
Give a very brief answer. -8.51e+06. What is the difference between the Aid flow (current US$) of Italy in 1983 and the Aid flow (current US$) of Japan in 1985?
Provide a succinct answer. -4.88e+06. What is the difference between the Aid flow (current US$) in France in 1983 and the Aid flow (current US$) in Germany in 1986?
Offer a very short reply. 8.75e+06. What is the difference between the Aid flow (current US$) of France in 1983 and the Aid flow (current US$) of Italy in 1986?
Offer a very short reply. 3.67e+06. What is the difference between the Aid flow (current US$) of France in 1983 and the Aid flow (current US$) of Japan in 1986?
Give a very brief answer. 4.49e+06. What is the difference between the Aid flow (current US$) of Germany in 1983 and the Aid flow (current US$) of Italy in 1986?
Your answer should be very brief. -5.13e+06. What is the difference between the Aid flow (current US$) in Germany in 1983 and the Aid flow (current US$) in Japan in 1986?
Offer a very short reply. -4.31e+06. What is the difference between the Aid flow (current US$) in Italy in 1983 and the Aid flow (current US$) in Japan in 1986?
Your answer should be compact. -6.80e+05. What is the difference between the Aid flow (current US$) in France in 1983 and the Aid flow (current US$) in Germany in 1987?
Provide a succinct answer. 8.64e+06. What is the difference between the Aid flow (current US$) in France in 1983 and the Aid flow (current US$) in Italy in 1987?
Give a very brief answer. -1.73e+07. What is the difference between the Aid flow (current US$) of France in 1983 and the Aid flow (current US$) of Japan in 1987?
Provide a succinct answer. 10000. What is the difference between the Aid flow (current US$) of Germany in 1983 and the Aid flow (current US$) of Italy in 1987?
Ensure brevity in your answer.  -2.61e+07. What is the difference between the Aid flow (current US$) of Germany in 1983 and the Aid flow (current US$) of Japan in 1987?
Provide a short and direct response. -8.79e+06. What is the difference between the Aid flow (current US$) in Italy in 1983 and the Aid flow (current US$) in Japan in 1987?
Your answer should be compact. -5.16e+06. What is the difference between the Aid flow (current US$) in France in 1983 and the Aid flow (current US$) in Germany in 1988?
Your response must be concise. 8.57e+06. What is the difference between the Aid flow (current US$) in France in 1983 and the Aid flow (current US$) in Italy in 1988?
Provide a succinct answer. -2.22e+06. What is the difference between the Aid flow (current US$) of France in 1983 and the Aid flow (current US$) of Japan in 1988?
Your answer should be compact. -1.73e+07. What is the difference between the Aid flow (current US$) of Germany in 1983 and the Aid flow (current US$) of Italy in 1988?
Give a very brief answer. -1.10e+07. What is the difference between the Aid flow (current US$) of Germany in 1983 and the Aid flow (current US$) of Japan in 1988?
Offer a terse response. -2.61e+07. What is the difference between the Aid flow (current US$) in Italy in 1983 and the Aid flow (current US$) in Japan in 1988?
Offer a terse response. -2.25e+07. What is the difference between the Aid flow (current US$) of France in 1984 and the Aid flow (current US$) of Germany in 1985?
Your response must be concise. 6.62e+06. What is the difference between the Aid flow (current US$) of France in 1984 and the Aid flow (current US$) of Italy in 1985?
Your answer should be very brief. -8.10e+05. What is the difference between the Aid flow (current US$) of France in 1984 and the Aid flow (current US$) of Japan in 1985?
Your response must be concise. -1.88e+06. What is the difference between the Aid flow (current US$) of Germany in 1984 and the Aid flow (current US$) of Italy in 1985?
Provide a succinct answer. -5.89e+06. What is the difference between the Aid flow (current US$) of Germany in 1984 and the Aid flow (current US$) of Japan in 1985?
Your answer should be very brief. -6.96e+06. What is the difference between the Aid flow (current US$) of Italy in 1984 and the Aid flow (current US$) of Japan in 1985?
Your answer should be compact. 8.50e+06. What is the difference between the Aid flow (current US$) in France in 1984 and the Aid flow (current US$) in Germany in 1986?
Give a very brief answer. 6.58e+06. What is the difference between the Aid flow (current US$) of France in 1984 and the Aid flow (current US$) of Italy in 1986?
Offer a terse response. 1.50e+06. What is the difference between the Aid flow (current US$) in France in 1984 and the Aid flow (current US$) in Japan in 1986?
Your answer should be very brief. 2.32e+06. What is the difference between the Aid flow (current US$) of Germany in 1984 and the Aid flow (current US$) of Italy in 1986?
Give a very brief answer. -3.58e+06. What is the difference between the Aid flow (current US$) in Germany in 1984 and the Aid flow (current US$) in Japan in 1986?
Offer a very short reply. -2.76e+06. What is the difference between the Aid flow (current US$) of Italy in 1984 and the Aid flow (current US$) of Japan in 1986?
Provide a short and direct response. 1.27e+07. What is the difference between the Aid flow (current US$) of France in 1984 and the Aid flow (current US$) of Germany in 1987?
Your answer should be compact. 6.47e+06. What is the difference between the Aid flow (current US$) of France in 1984 and the Aid flow (current US$) of Italy in 1987?
Give a very brief answer. -1.94e+07. What is the difference between the Aid flow (current US$) of France in 1984 and the Aid flow (current US$) of Japan in 1987?
Ensure brevity in your answer.  -2.16e+06. What is the difference between the Aid flow (current US$) of Germany in 1984 and the Aid flow (current US$) of Italy in 1987?
Offer a very short reply. -2.45e+07. What is the difference between the Aid flow (current US$) in Germany in 1984 and the Aid flow (current US$) in Japan in 1987?
Offer a terse response. -7.24e+06. What is the difference between the Aid flow (current US$) of Italy in 1984 and the Aid flow (current US$) of Japan in 1987?
Give a very brief answer. 8.22e+06. What is the difference between the Aid flow (current US$) of France in 1984 and the Aid flow (current US$) of Germany in 1988?
Offer a very short reply. 6.40e+06. What is the difference between the Aid flow (current US$) in France in 1984 and the Aid flow (current US$) in Italy in 1988?
Your answer should be compact. -4.39e+06. What is the difference between the Aid flow (current US$) in France in 1984 and the Aid flow (current US$) in Japan in 1988?
Keep it short and to the point. -1.95e+07. What is the difference between the Aid flow (current US$) in Germany in 1984 and the Aid flow (current US$) in Italy in 1988?
Offer a terse response. -9.47e+06. What is the difference between the Aid flow (current US$) in Germany in 1984 and the Aid flow (current US$) in Japan in 1988?
Make the answer very short. -2.46e+07. What is the difference between the Aid flow (current US$) in Italy in 1984 and the Aid flow (current US$) in Japan in 1988?
Make the answer very short. -9.10e+06. What is the difference between the Aid flow (current US$) in France in 1985 and the Aid flow (current US$) in Germany in 1986?
Offer a very short reply. 5.20e+06. What is the difference between the Aid flow (current US$) of France in 1985 and the Aid flow (current US$) of Japan in 1986?
Ensure brevity in your answer.  9.40e+05. What is the difference between the Aid flow (current US$) of Germany in 1985 and the Aid flow (current US$) of Italy in 1986?
Provide a short and direct response. -5.12e+06. What is the difference between the Aid flow (current US$) in Germany in 1985 and the Aid flow (current US$) in Japan in 1986?
Your answer should be very brief. -4.30e+06. What is the difference between the Aid flow (current US$) in Italy in 1985 and the Aid flow (current US$) in Japan in 1986?
Make the answer very short. 3.13e+06. What is the difference between the Aid flow (current US$) in France in 1985 and the Aid flow (current US$) in Germany in 1987?
Provide a short and direct response. 5.09e+06. What is the difference between the Aid flow (current US$) in France in 1985 and the Aid flow (current US$) in Italy in 1987?
Make the answer very short. -2.08e+07. What is the difference between the Aid flow (current US$) in France in 1985 and the Aid flow (current US$) in Japan in 1987?
Give a very brief answer. -3.54e+06. What is the difference between the Aid flow (current US$) of Germany in 1985 and the Aid flow (current US$) of Italy in 1987?
Your response must be concise. -2.60e+07. What is the difference between the Aid flow (current US$) of Germany in 1985 and the Aid flow (current US$) of Japan in 1987?
Provide a short and direct response. -8.78e+06. What is the difference between the Aid flow (current US$) in Italy in 1985 and the Aid flow (current US$) in Japan in 1987?
Your answer should be very brief. -1.35e+06. What is the difference between the Aid flow (current US$) of France in 1985 and the Aid flow (current US$) of Germany in 1988?
Your answer should be compact. 5.02e+06. What is the difference between the Aid flow (current US$) of France in 1985 and the Aid flow (current US$) of Italy in 1988?
Your response must be concise. -5.77e+06. What is the difference between the Aid flow (current US$) in France in 1985 and the Aid flow (current US$) in Japan in 1988?
Keep it short and to the point. -2.09e+07. What is the difference between the Aid flow (current US$) of Germany in 1985 and the Aid flow (current US$) of Italy in 1988?
Offer a terse response. -1.10e+07. What is the difference between the Aid flow (current US$) of Germany in 1985 and the Aid flow (current US$) of Japan in 1988?
Offer a very short reply. -2.61e+07. What is the difference between the Aid flow (current US$) of Italy in 1985 and the Aid flow (current US$) of Japan in 1988?
Provide a succinct answer. -1.87e+07. What is the difference between the Aid flow (current US$) in France in 1986 and the Aid flow (current US$) in Germany in 1987?
Your response must be concise. 4.92e+06. What is the difference between the Aid flow (current US$) in France in 1986 and the Aid flow (current US$) in Italy in 1987?
Offer a very short reply. -2.10e+07. What is the difference between the Aid flow (current US$) in France in 1986 and the Aid flow (current US$) in Japan in 1987?
Provide a short and direct response. -3.71e+06. What is the difference between the Aid flow (current US$) in Germany in 1986 and the Aid flow (current US$) in Italy in 1987?
Your answer should be compact. -2.60e+07. What is the difference between the Aid flow (current US$) of Germany in 1986 and the Aid flow (current US$) of Japan in 1987?
Ensure brevity in your answer.  -8.74e+06. What is the difference between the Aid flow (current US$) of Italy in 1986 and the Aid flow (current US$) of Japan in 1987?
Give a very brief answer. -3.66e+06. What is the difference between the Aid flow (current US$) of France in 1986 and the Aid flow (current US$) of Germany in 1988?
Your response must be concise. 4.85e+06. What is the difference between the Aid flow (current US$) in France in 1986 and the Aid flow (current US$) in Italy in 1988?
Provide a short and direct response. -5.94e+06. What is the difference between the Aid flow (current US$) of France in 1986 and the Aid flow (current US$) of Japan in 1988?
Your response must be concise. -2.10e+07. What is the difference between the Aid flow (current US$) in Germany in 1986 and the Aid flow (current US$) in Italy in 1988?
Your answer should be compact. -1.10e+07. What is the difference between the Aid flow (current US$) in Germany in 1986 and the Aid flow (current US$) in Japan in 1988?
Provide a succinct answer. -2.61e+07. What is the difference between the Aid flow (current US$) of Italy in 1986 and the Aid flow (current US$) of Japan in 1988?
Offer a terse response. -2.10e+07. What is the difference between the Aid flow (current US$) of France in 1987 and the Aid flow (current US$) of Germany in 1988?
Ensure brevity in your answer.  1.44e+07. What is the difference between the Aid flow (current US$) of France in 1987 and the Aid flow (current US$) of Italy in 1988?
Offer a very short reply. 3.62e+06. What is the difference between the Aid flow (current US$) in France in 1987 and the Aid flow (current US$) in Japan in 1988?
Your answer should be very brief. -1.15e+07. What is the difference between the Aid flow (current US$) in Germany in 1987 and the Aid flow (current US$) in Italy in 1988?
Offer a very short reply. -1.09e+07. What is the difference between the Aid flow (current US$) in Germany in 1987 and the Aid flow (current US$) in Japan in 1988?
Give a very brief answer. -2.60e+07. What is the difference between the Aid flow (current US$) of Italy in 1987 and the Aid flow (current US$) of Japan in 1988?
Make the answer very short. -5.00e+04. What is the average Aid flow (current US$) of France per year?
Your answer should be very brief. 6.79e+06. What is the average Aid flow (current US$) of Germany per year?
Make the answer very short. 2.67e+05. What is the average Aid flow (current US$) in Italy per year?
Keep it short and to the point. 8.79e+06. What is the average Aid flow (current US$) in Japan per year?
Ensure brevity in your answer.  9.56e+06. In the year 1980, what is the difference between the Aid flow (current US$) in France and Aid flow (current US$) in Germany?
Offer a very short reply. 8.90e+05. In the year 1980, what is the difference between the Aid flow (current US$) in France and Aid flow (current US$) in Italy?
Ensure brevity in your answer.  -1.72e+06. In the year 1980, what is the difference between the Aid flow (current US$) of France and Aid flow (current US$) of Japan?
Provide a short and direct response. 8.60e+05. In the year 1980, what is the difference between the Aid flow (current US$) in Germany and Aid flow (current US$) in Italy?
Your answer should be compact. -2.61e+06. In the year 1980, what is the difference between the Aid flow (current US$) of Germany and Aid flow (current US$) of Japan?
Provide a succinct answer. -3.00e+04. In the year 1980, what is the difference between the Aid flow (current US$) of Italy and Aid flow (current US$) of Japan?
Your answer should be very brief. 2.58e+06. In the year 1981, what is the difference between the Aid flow (current US$) in France and Aid flow (current US$) in Italy?
Ensure brevity in your answer.  -4.09e+06. In the year 1981, what is the difference between the Aid flow (current US$) in France and Aid flow (current US$) in Japan?
Your response must be concise. -3.06e+06. In the year 1981, what is the difference between the Aid flow (current US$) of Germany and Aid flow (current US$) of Italy?
Give a very brief answer. -4.29e+06. In the year 1981, what is the difference between the Aid flow (current US$) of Germany and Aid flow (current US$) of Japan?
Give a very brief answer. -3.26e+06. In the year 1981, what is the difference between the Aid flow (current US$) in Italy and Aid flow (current US$) in Japan?
Ensure brevity in your answer.  1.03e+06. In the year 1982, what is the difference between the Aid flow (current US$) in France and Aid flow (current US$) in Germany?
Make the answer very short. 8.29e+06. In the year 1982, what is the difference between the Aid flow (current US$) in France and Aid flow (current US$) in Italy?
Offer a very short reply. 6.74e+06. In the year 1982, what is the difference between the Aid flow (current US$) of France and Aid flow (current US$) of Japan?
Provide a short and direct response. 1.99e+06. In the year 1982, what is the difference between the Aid flow (current US$) in Germany and Aid flow (current US$) in Italy?
Give a very brief answer. -1.55e+06. In the year 1982, what is the difference between the Aid flow (current US$) of Germany and Aid flow (current US$) of Japan?
Provide a short and direct response. -6.30e+06. In the year 1982, what is the difference between the Aid flow (current US$) of Italy and Aid flow (current US$) of Japan?
Provide a short and direct response. -4.75e+06. In the year 1983, what is the difference between the Aid flow (current US$) in France and Aid flow (current US$) in Germany?
Your answer should be compact. 8.80e+06. In the year 1983, what is the difference between the Aid flow (current US$) in France and Aid flow (current US$) in Italy?
Offer a very short reply. 5.17e+06. In the year 1983, what is the difference between the Aid flow (current US$) of France and Aid flow (current US$) of Japan?
Your response must be concise. -1.85e+06. In the year 1983, what is the difference between the Aid flow (current US$) of Germany and Aid flow (current US$) of Italy?
Your answer should be very brief. -3.63e+06. In the year 1983, what is the difference between the Aid flow (current US$) of Germany and Aid flow (current US$) of Japan?
Keep it short and to the point. -1.06e+07. In the year 1983, what is the difference between the Aid flow (current US$) in Italy and Aid flow (current US$) in Japan?
Your answer should be very brief. -7.02e+06. In the year 1984, what is the difference between the Aid flow (current US$) of France and Aid flow (current US$) of Germany?
Offer a terse response. 5.08e+06. In the year 1984, what is the difference between the Aid flow (current US$) of France and Aid flow (current US$) of Italy?
Offer a very short reply. -1.04e+07. In the year 1984, what is the difference between the Aid flow (current US$) in France and Aid flow (current US$) in Japan?
Keep it short and to the point. -1.10e+07. In the year 1984, what is the difference between the Aid flow (current US$) of Germany and Aid flow (current US$) of Italy?
Offer a very short reply. -1.55e+07. In the year 1984, what is the difference between the Aid flow (current US$) of Germany and Aid flow (current US$) of Japan?
Ensure brevity in your answer.  -1.61e+07. In the year 1984, what is the difference between the Aid flow (current US$) of Italy and Aid flow (current US$) of Japan?
Provide a short and direct response. -6.30e+05. In the year 1985, what is the difference between the Aid flow (current US$) of France and Aid flow (current US$) of Germany?
Your answer should be compact. 5.24e+06. In the year 1985, what is the difference between the Aid flow (current US$) in France and Aid flow (current US$) in Italy?
Your answer should be very brief. -2.19e+06. In the year 1985, what is the difference between the Aid flow (current US$) of France and Aid flow (current US$) of Japan?
Offer a very short reply. -3.26e+06. In the year 1985, what is the difference between the Aid flow (current US$) in Germany and Aid flow (current US$) in Italy?
Provide a short and direct response. -7.43e+06. In the year 1985, what is the difference between the Aid flow (current US$) of Germany and Aid flow (current US$) of Japan?
Provide a succinct answer. -8.50e+06. In the year 1985, what is the difference between the Aid flow (current US$) of Italy and Aid flow (current US$) of Japan?
Keep it short and to the point. -1.07e+06. In the year 1986, what is the difference between the Aid flow (current US$) in France and Aid flow (current US$) in Germany?
Provide a short and direct response. 5.03e+06. In the year 1986, what is the difference between the Aid flow (current US$) of France and Aid flow (current US$) of Japan?
Your answer should be compact. 7.70e+05. In the year 1986, what is the difference between the Aid flow (current US$) in Germany and Aid flow (current US$) in Italy?
Give a very brief answer. -5.08e+06. In the year 1986, what is the difference between the Aid flow (current US$) in Germany and Aid flow (current US$) in Japan?
Your response must be concise. -4.26e+06. In the year 1986, what is the difference between the Aid flow (current US$) of Italy and Aid flow (current US$) of Japan?
Your response must be concise. 8.20e+05. In the year 1987, what is the difference between the Aid flow (current US$) in France and Aid flow (current US$) in Germany?
Offer a terse response. 1.45e+07. In the year 1987, what is the difference between the Aid flow (current US$) of France and Aid flow (current US$) of Italy?
Provide a short and direct response. -1.14e+07. In the year 1987, what is the difference between the Aid flow (current US$) of France and Aid flow (current US$) of Japan?
Keep it short and to the point. 5.85e+06. In the year 1987, what is the difference between the Aid flow (current US$) of Germany and Aid flow (current US$) of Italy?
Provide a short and direct response. -2.59e+07. In the year 1987, what is the difference between the Aid flow (current US$) in Germany and Aid flow (current US$) in Japan?
Your response must be concise. -8.63e+06. In the year 1987, what is the difference between the Aid flow (current US$) of Italy and Aid flow (current US$) of Japan?
Offer a terse response. 1.73e+07. In the year 1988, what is the difference between the Aid flow (current US$) in France and Aid flow (current US$) in Germany?
Your response must be concise. 1.07e+07. In the year 1988, what is the difference between the Aid flow (current US$) in France and Aid flow (current US$) in Japan?
Your answer should be very brief. -1.52e+07. In the year 1988, what is the difference between the Aid flow (current US$) in Germany and Aid flow (current US$) in Italy?
Give a very brief answer. -1.08e+07. In the year 1988, what is the difference between the Aid flow (current US$) of Germany and Aid flow (current US$) of Japan?
Offer a terse response. -2.59e+07. In the year 1988, what is the difference between the Aid flow (current US$) of Italy and Aid flow (current US$) of Japan?
Your answer should be very brief. -1.51e+07. What is the ratio of the Aid flow (current US$) in France in 1980 to that in 1981?
Make the answer very short. 3.28. What is the ratio of the Aid flow (current US$) of Italy in 1980 to that in 1981?
Provide a succinct answer. 0.61. What is the ratio of the Aid flow (current US$) of Japan in 1980 to that in 1981?
Give a very brief answer. 0.03. What is the ratio of the Aid flow (current US$) of France in 1980 to that in 1982?
Give a very brief answer. 0.11. What is the ratio of the Aid flow (current US$) in Germany in 1980 to that in 1982?
Your answer should be compact. 0.86. What is the ratio of the Aid flow (current US$) in Italy in 1980 to that in 1982?
Your answer should be very brief. 1.65. What is the ratio of the Aid flow (current US$) of Japan in 1980 to that in 1982?
Keep it short and to the point. 0.01. What is the ratio of the Aid flow (current US$) in France in 1980 to that in 1983?
Ensure brevity in your answer.  0.11. What is the ratio of the Aid flow (current US$) of Italy in 1980 to that in 1983?
Offer a very short reply. 0.73. What is the ratio of the Aid flow (current US$) of Japan in 1980 to that in 1983?
Give a very brief answer. 0.01. What is the ratio of the Aid flow (current US$) of France in 1980 to that in 1984?
Keep it short and to the point. 0.14. What is the ratio of the Aid flow (current US$) of Germany in 1980 to that in 1984?
Your answer should be very brief. 0.04. What is the ratio of the Aid flow (current US$) in Italy in 1980 to that in 1984?
Provide a succinct answer. 0.16. What is the ratio of the Aid flow (current US$) in Japan in 1980 to that in 1984?
Your response must be concise. 0.01. What is the ratio of the Aid flow (current US$) of France in 1980 to that in 1985?
Your answer should be compact. 0.18. What is the ratio of the Aid flow (current US$) in Germany in 1980 to that in 1985?
Keep it short and to the point. 1.5. What is the ratio of the Aid flow (current US$) of Italy in 1980 to that in 1985?
Your answer should be very brief. 0.36. What is the ratio of the Aid flow (current US$) of Japan in 1980 to that in 1985?
Keep it short and to the point. 0.01. What is the ratio of the Aid flow (current US$) of France in 1980 to that in 1986?
Your response must be concise. 0.19. What is the ratio of the Aid flow (current US$) of Germany in 1980 to that in 1986?
Ensure brevity in your answer.  0.75. What is the ratio of the Aid flow (current US$) of Italy in 1980 to that in 1986?
Provide a succinct answer. 0.52. What is the ratio of the Aid flow (current US$) in Japan in 1980 to that in 1986?
Keep it short and to the point. 0.02. What is the ratio of the Aid flow (current US$) in France in 1980 to that in 1987?
Your response must be concise. 0.06. What is the ratio of the Aid flow (current US$) of Germany in 1980 to that in 1987?
Offer a terse response. 0.32. What is the ratio of the Aid flow (current US$) in Italy in 1980 to that in 1987?
Your response must be concise. 0.1. What is the ratio of the Aid flow (current US$) of Japan in 1980 to that in 1987?
Your answer should be very brief. 0.01. What is the ratio of the Aid flow (current US$) in France in 1980 to that in 1988?
Provide a short and direct response. 0.09. What is the ratio of the Aid flow (current US$) of Germany in 1980 to that in 1988?
Give a very brief answer. 0.23. What is the ratio of the Aid flow (current US$) in Italy in 1980 to that in 1988?
Ensure brevity in your answer.  0.24. What is the ratio of the Aid flow (current US$) in Japan in 1980 to that in 1988?
Your answer should be compact. 0. What is the ratio of the Aid flow (current US$) in France in 1981 to that in 1982?
Offer a very short reply. 0.03. What is the ratio of the Aid flow (current US$) of Italy in 1981 to that in 1982?
Provide a succinct answer. 2.7. What is the ratio of the Aid flow (current US$) in Japan in 1981 to that in 1982?
Make the answer very short. 0.53. What is the ratio of the Aid flow (current US$) of France in 1981 to that in 1983?
Provide a succinct answer. 0.03. What is the ratio of the Aid flow (current US$) of Italy in 1981 to that in 1983?
Keep it short and to the point. 1.2. What is the ratio of the Aid flow (current US$) in Japan in 1981 to that in 1983?
Your answer should be compact. 0.31. What is the ratio of the Aid flow (current US$) of France in 1981 to that in 1984?
Your answer should be compact. 0.04. What is the ratio of the Aid flow (current US$) in Germany in 1981 to that in 1984?
Offer a very short reply. 0.06. What is the ratio of the Aid flow (current US$) of Italy in 1981 to that in 1984?
Provide a succinct answer. 0.26. What is the ratio of the Aid flow (current US$) of Japan in 1981 to that in 1984?
Offer a very short reply. 0.19. What is the ratio of the Aid flow (current US$) of France in 1981 to that in 1985?
Offer a terse response. 0.05. What is the ratio of the Aid flow (current US$) in Germany in 1981 to that in 1985?
Your answer should be very brief. 2.25. What is the ratio of the Aid flow (current US$) of Italy in 1981 to that in 1985?
Your answer should be compact. 0.59. What is the ratio of the Aid flow (current US$) of Japan in 1981 to that in 1985?
Make the answer very short. 0.39. What is the ratio of the Aid flow (current US$) in France in 1981 to that in 1986?
Your answer should be very brief. 0.06. What is the ratio of the Aid flow (current US$) in Italy in 1981 to that in 1986?
Your answer should be very brief. 0.85. What is the ratio of the Aid flow (current US$) in Japan in 1981 to that in 1986?
Your response must be concise. 0.77. What is the ratio of the Aid flow (current US$) of France in 1981 to that in 1987?
Make the answer very short. 0.02. What is the ratio of the Aid flow (current US$) in Germany in 1981 to that in 1987?
Keep it short and to the point. 0.47. What is the ratio of the Aid flow (current US$) in Italy in 1981 to that in 1987?
Offer a terse response. 0.17. What is the ratio of the Aid flow (current US$) in Japan in 1981 to that in 1987?
Your answer should be compact. 0.38. What is the ratio of the Aid flow (current US$) of France in 1981 to that in 1988?
Provide a succinct answer. 0.03. What is the ratio of the Aid flow (current US$) in Germany in 1981 to that in 1988?
Offer a very short reply. 0.35. What is the ratio of the Aid flow (current US$) of Italy in 1981 to that in 1988?
Offer a terse response. 0.4. What is the ratio of the Aid flow (current US$) of Japan in 1981 to that in 1988?
Keep it short and to the point. 0.13. What is the ratio of the Aid flow (current US$) of France in 1982 to that in 1983?
Your answer should be very brief. 0.95. What is the ratio of the Aid flow (current US$) in Germany in 1982 to that in 1983?
Give a very brief answer. 2.33. What is the ratio of the Aid flow (current US$) of Italy in 1982 to that in 1983?
Your answer should be very brief. 0.44. What is the ratio of the Aid flow (current US$) in Japan in 1982 to that in 1983?
Provide a short and direct response. 0.6. What is the ratio of the Aid flow (current US$) of France in 1982 to that in 1984?
Offer a terse response. 1.26. What is the ratio of the Aid flow (current US$) of Germany in 1982 to that in 1984?
Your answer should be compact. 0.04. What is the ratio of the Aid flow (current US$) of Italy in 1982 to that in 1984?
Provide a succinct answer. 0.1. What is the ratio of the Aid flow (current US$) in Japan in 1982 to that in 1984?
Keep it short and to the point. 0.36. What is the ratio of the Aid flow (current US$) of France in 1982 to that in 1985?
Give a very brief answer. 1.58. What is the ratio of the Aid flow (current US$) in Italy in 1982 to that in 1985?
Make the answer very short. 0.22. What is the ratio of the Aid flow (current US$) in Japan in 1982 to that in 1985?
Keep it short and to the point. 0.75. What is the ratio of the Aid flow (current US$) of France in 1982 to that in 1986?
Make the answer very short. 1.64. What is the ratio of the Aid flow (current US$) of Italy in 1982 to that in 1986?
Provide a succinct answer. 0.31. What is the ratio of the Aid flow (current US$) in Japan in 1982 to that in 1986?
Provide a short and direct response. 1.47. What is the ratio of the Aid flow (current US$) of France in 1982 to that in 1987?
Give a very brief answer. 0.57. What is the ratio of the Aid flow (current US$) of Germany in 1982 to that in 1987?
Ensure brevity in your answer.  0.37. What is the ratio of the Aid flow (current US$) in Italy in 1982 to that in 1987?
Offer a very short reply. 0.06. What is the ratio of the Aid flow (current US$) of Japan in 1982 to that in 1987?
Offer a very short reply. 0.72. What is the ratio of the Aid flow (current US$) in France in 1982 to that in 1988?
Your response must be concise. 0.76. What is the ratio of the Aid flow (current US$) of Germany in 1982 to that in 1988?
Your response must be concise. 0.27. What is the ratio of the Aid flow (current US$) in Italy in 1982 to that in 1988?
Your response must be concise. 0.15. What is the ratio of the Aid flow (current US$) in Japan in 1982 to that in 1988?
Provide a succinct answer. 0.24. What is the ratio of the Aid flow (current US$) of France in 1983 to that in 1984?
Your answer should be very brief. 1.33. What is the ratio of the Aid flow (current US$) of Germany in 1983 to that in 1984?
Your answer should be compact. 0.02. What is the ratio of the Aid flow (current US$) in Italy in 1983 to that in 1984?
Give a very brief answer. 0.21. What is the ratio of the Aid flow (current US$) in Japan in 1983 to that in 1984?
Make the answer very short. 0.6. What is the ratio of the Aid flow (current US$) in France in 1983 to that in 1985?
Make the answer very short. 1.67. What is the ratio of the Aid flow (current US$) in Italy in 1983 to that in 1985?
Provide a short and direct response. 0.49. What is the ratio of the Aid flow (current US$) in Japan in 1983 to that in 1985?
Offer a terse response. 1.25. What is the ratio of the Aid flow (current US$) in France in 1983 to that in 1986?
Keep it short and to the point. 1.73. What is the ratio of the Aid flow (current US$) in Germany in 1983 to that in 1986?
Your answer should be very brief. 0.38. What is the ratio of the Aid flow (current US$) in Italy in 1983 to that in 1986?
Offer a terse response. 0.71. What is the ratio of the Aid flow (current US$) in Japan in 1983 to that in 1986?
Ensure brevity in your answer.  2.46. What is the ratio of the Aid flow (current US$) in France in 1983 to that in 1987?
Give a very brief answer. 0.6. What is the ratio of the Aid flow (current US$) of Germany in 1983 to that in 1987?
Your response must be concise. 0.16. What is the ratio of the Aid flow (current US$) of Italy in 1983 to that in 1987?
Offer a terse response. 0.14. What is the ratio of the Aid flow (current US$) in Japan in 1983 to that in 1987?
Give a very brief answer. 1.21. What is the ratio of the Aid flow (current US$) of France in 1983 to that in 1988?
Give a very brief answer. 0.8. What is the ratio of the Aid flow (current US$) in Germany in 1983 to that in 1988?
Your answer should be very brief. 0.12. What is the ratio of the Aid flow (current US$) in Italy in 1983 to that in 1988?
Provide a succinct answer. 0.33. What is the ratio of the Aid flow (current US$) of Japan in 1983 to that in 1988?
Offer a very short reply. 0.41. What is the ratio of the Aid flow (current US$) in France in 1984 to that in 1985?
Your response must be concise. 1.26. What is the ratio of the Aid flow (current US$) in Germany in 1984 to that in 1985?
Ensure brevity in your answer.  39.5. What is the ratio of the Aid flow (current US$) in Italy in 1984 to that in 1985?
Your answer should be very brief. 2.28. What is the ratio of the Aid flow (current US$) of Japan in 1984 to that in 1985?
Your answer should be compact. 2.07. What is the ratio of the Aid flow (current US$) of France in 1984 to that in 1986?
Provide a short and direct response. 1.3. What is the ratio of the Aid flow (current US$) of Germany in 1984 to that in 1986?
Keep it short and to the point. 19.75. What is the ratio of the Aid flow (current US$) of Italy in 1984 to that in 1986?
Give a very brief answer. 3.3. What is the ratio of the Aid flow (current US$) of Japan in 1984 to that in 1986?
Make the answer very short. 4.07. What is the ratio of the Aid flow (current US$) of France in 1984 to that in 1987?
Make the answer very short. 0.45. What is the ratio of the Aid flow (current US$) of Germany in 1984 to that in 1987?
Provide a short and direct response. 8.32. What is the ratio of the Aid flow (current US$) in Italy in 1984 to that in 1987?
Offer a terse response. 0.65. What is the ratio of the Aid flow (current US$) in Japan in 1984 to that in 1987?
Make the answer very short. 2. What is the ratio of the Aid flow (current US$) in France in 1984 to that in 1988?
Your answer should be very brief. 0.61. What is the ratio of the Aid flow (current US$) in Germany in 1984 to that in 1988?
Give a very brief answer. 6.08. What is the ratio of the Aid flow (current US$) of Italy in 1984 to that in 1988?
Ensure brevity in your answer.  1.54. What is the ratio of the Aid flow (current US$) of Japan in 1984 to that in 1988?
Offer a very short reply. 0.68. What is the ratio of the Aid flow (current US$) in France in 1985 to that in 1986?
Provide a short and direct response. 1.03. What is the ratio of the Aid flow (current US$) in Italy in 1985 to that in 1986?
Provide a succinct answer. 1.45. What is the ratio of the Aid flow (current US$) in Japan in 1985 to that in 1986?
Offer a very short reply. 1.97. What is the ratio of the Aid flow (current US$) in France in 1985 to that in 1987?
Give a very brief answer. 0.36. What is the ratio of the Aid flow (current US$) of Germany in 1985 to that in 1987?
Provide a short and direct response. 0.21. What is the ratio of the Aid flow (current US$) of Italy in 1985 to that in 1987?
Keep it short and to the point. 0.29. What is the ratio of the Aid flow (current US$) in Japan in 1985 to that in 1987?
Ensure brevity in your answer.  0.97. What is the ratio of the Aid flow (current US$) in France in 1985 to that in 1988?
Provide a succinct answer. 0.48. What is the ratio of the Aid flow (current US$) in Germany in 1985 to that in 1988?
Your response must be concise. 0.15. What is the ratio of the Aid flow (current US$) of Italy in 1985 to that in 1988?
Offer a terse response. 0.68. What is the ratio of the Aid flow (current US$) of Japan in 1985 to that in 1988?
Provide a short and direct response. 0.33. What is the ratio of the Aid flow (current US$) in France in 1986 to that in 1987?
Make the answer very short. 0.35. What is the ratio of the Aid flow (current US$) in Germany in 1986 to that in 1987?
Keep it short and to the point. 0.42. What is the ratio of the Aid flow (current US$) of Italy in 1986 to that in 1987?
Offer a very short reply. 0.2. What is the ratio of the Aid flow (current US$) of Japan in 1986 to that in 1987?
Keep it short and to the point. 0.49. What is the ratio of the Aid flow (current US$) of France in 1986 to that in 1988?
Ensure brevity in your answer.  0.47. What is the ratio of the Aid flow (current US$) of Germany in 1986 to that in 1988?
Give a very brief answer. 0.31. What is the ratio of the Aid flow (current US$) in Italy in 1986 to that in 1988?
Ensure brevity in your answer.  0.47. What is the ratio of the Aid flow (current US$) in Japan in 1986 to that in 1988?
Your answer should be very brief. 0.17. What is the ratio of the Aid flow (current US$) in France in 1987 to that in 1988?
Keep it short and to the point. 1.34. What is the ratio of the Aid flow (current US$) of Germany in 1987 to that in 1988?
Offer a very short reply. 0.73. What is the ratio of the Aid flow (current US$) of Italy in 1987 to that in 1988?
Offer a terse response. 2.36. What is the ratio of the Aid flow (current US$) of Japan in 1987 to that in 1988?
Your response must be concise. 0.34. What is the difference between the highest and the second highest Aid flow (current US$) of France?
Give a very brief answer. 3.69e+06. What is the difference between the highest and the second highest Aid flow (current US$) in Germany?
Keep it short and to the point. 1.32e+06. What is the difference between the highest and the second highest Aid flow (current US$) in Italy?
Your response must be concise. 9.05e+06. What is the difference between the highest and the second highest Aid flow (current US$) in Japan?
Keep it short and to the point. 8.47e+06. What is the difference between the highest and the lowest Aid flow (current US$) in France?
Make the answer very short. 1.44e+07. What is the difference between the highest and the lowest Aid flow (current US$) in Germany?
Give a very brief answer. 1.55e+06. What is the difference between the highest and the lowest Aid flow (current US$) in Italy?
Ensure brevity in your answer.  2.45e+07. What is the difference between the highest and the lowest Aid flow (current US$) of Japan?
Offer a terse response. 2.60e+07. 